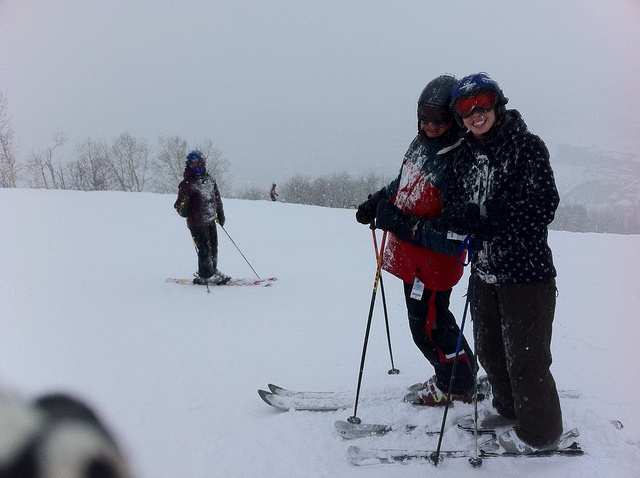Describe the objects in this image and their specific colors. I can see people in darkgray, black, and gray tones, people in darkgray, black, maroon, and gray tones, people in darkgray, black, and gray tones, skis in darkgray and gray tones, and skis in darkgray, gray, and lightgray tones in this image. 